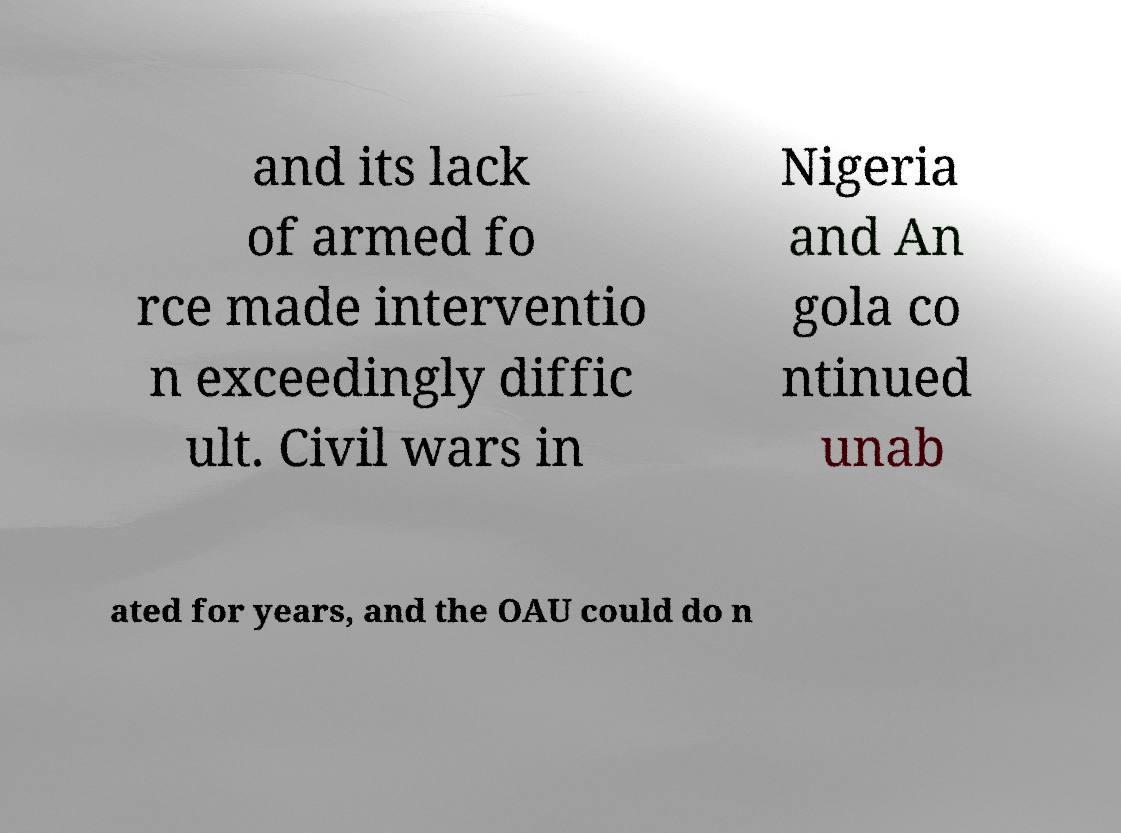Could you assist in decoding the text presented in this image and type it out clearly? and its lack of armed fo rce made interventio n exceedingly diffic ult. Civil wars in Nigeria and An gola co ntinued unab ated for years, and the OAU could do n 